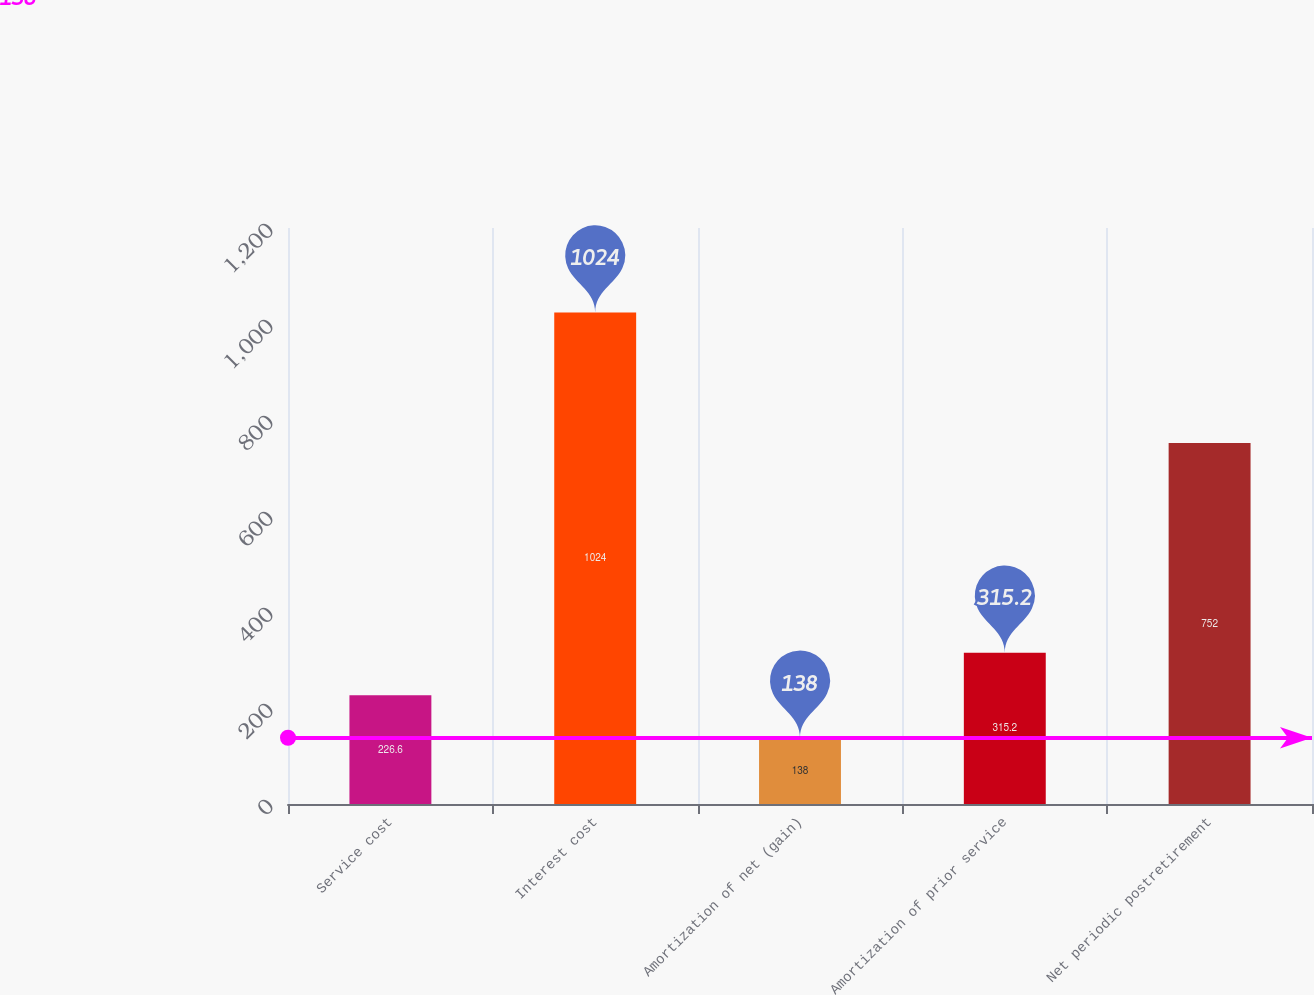Convert chart. <chart><loc_0><loc_0><loc_500><loc_500><bar_chart><fcel>Service cost<fcel>Interest cost<fcel>Amortization of net (gain)<fcel>Amortization of prior service<fcel>Net periodic postretirement<nl><fcel>226.6<fcel>1024<fcel>138<fcel>315.2<fcel>752<nl></chart> 